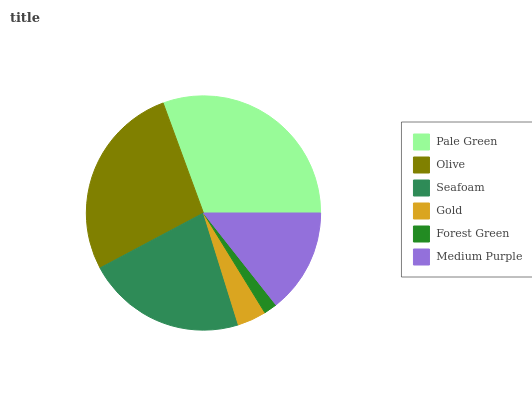Is Forest Green the minimum?
Answer yes or no. Yes. Is Pale Green the maximum?
Answer yes or no. Yes. Is Olive the minimum?
Answer yes or no. No. Is Olive the maximum?
Answer yes or no. No. Is Pale Green greater than Olive?
Answer yes or no. Yes. Is Olive less than Pale Green?
Answer yes or no. Yes. Is Olive greater than Pale Green?
Answer yes or no. No. Is Pale Green less than Olive?
Answer yes or no. No. Is Seafoam the high median?
Answer yes or no. Yes. Is Medium Purple the low median?
Answer yes or no. Yes. Is Olive the high median?
Answer yes or no. No. Is Gold the low median?
Answer yes or no. No. 